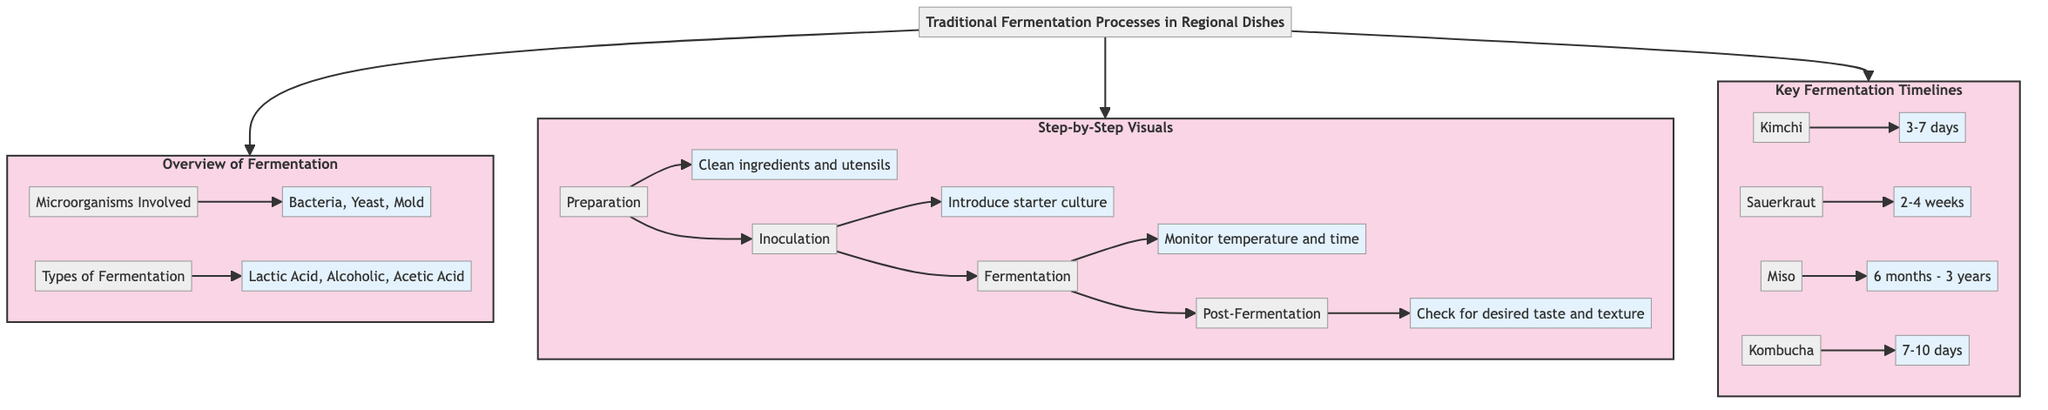What types of microorganisms are involved in fermentation? The diagram states that the microorganisms involved in fermentation include "Bacteria, Yeast, Mold." This information is found under the "Microorganisms Involved" node in the Overview section.
Answer: Bacteria, Yeast, Mold How many types of fermentation are listed in the diagram? The diagram lists three types of fermentation under the "Types of Fermentation" node: "Lactic Acid, Alcoholic, Acetic Acid." Therefore, there are three types provided.
Answer: 3 What is the first step in the fermentation process? The first step mentioned in the "Step-by-Step Visuals" section is "Preparation," which involves cleaning ingredients and utensils. This directly follows from the sequence outlined in the diagram.
Answer: Preparation How long does it take to ferment kombucha? The diagram specifies "7-10 days" as the fermentation timeline for kombucha under the "Key Fermentation Timelines" section. This information is directly presented in the timeline associated with kombucha.
Answer: 7-10 days What is the post-fermentation step? According to the diagram, the "Post-Fermentation" step involves checking for desired taste and texture. This is the final step in the process outlined in the "Step-by-Step Visuals" section.
Answer: Check for desired taste and texture Which dish has the longest fermentation timeline? The diagram indicates that "Miso" has a fermentation timeline of "6 months - 3 years," making it the dish with the longest fermentation period among the listed items in the timeline.
Answer: Miso What is the second step in the fermentation process? The second step outlined in the "Step-by-Step Visuals" section of the diagram is "Inoculation," which involves introducing a starter culture. This is the next step that follows preparation.
Answer: Inoculation What fermentation type is associated with lactic acid? The diagram lists "Lactic Acid" under the "Types of Fermentation" section, indicating that it is one of the fermentation types explicitly mentioned.
Answer: Lactic Acid 